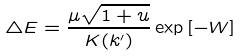<formula> <loc_0><loc_0><loc_500><loc_500>\triangle E = \frac { \mu \sqrt { 1 + u } } { K ( k ^ { \prime } ) } \exp { [ - W ] }</formula> 